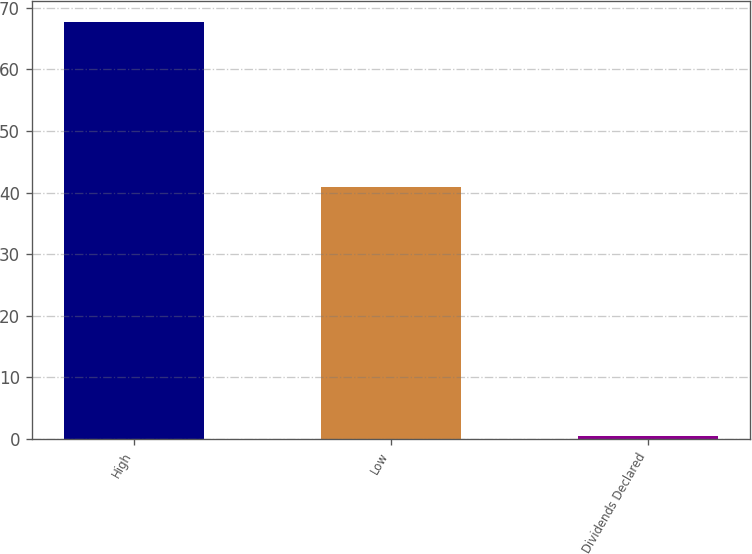<chart> <loc_0><loc_0><loc_500><loc_500><bar_chart><fcel>High<fcel>Low<fcel>Dividends Declared<nl><fcel>67.74<fcel>40.99<fcel>0.53<nl></chart> 